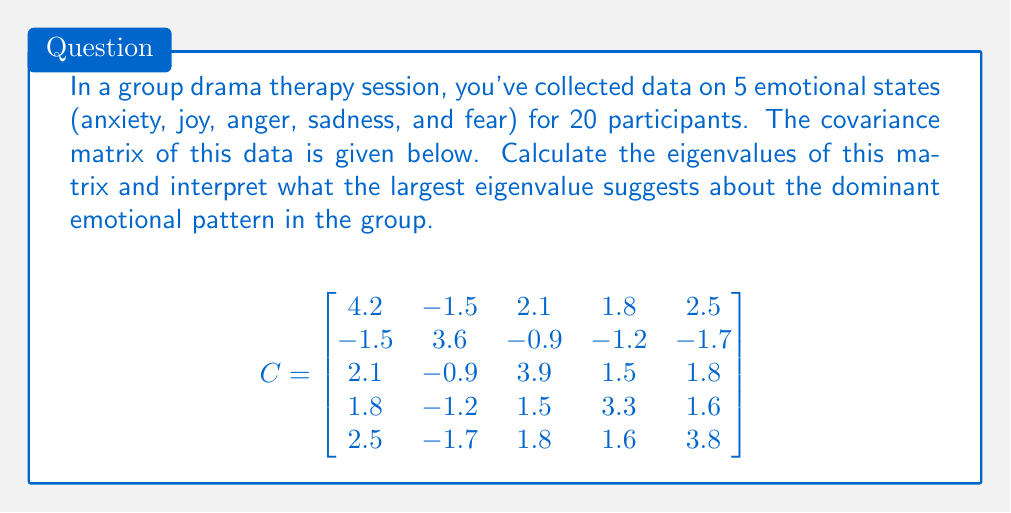Can you answer this question? To solve this problem, we'll follow these steps:

1) Calculate the eigenvalues of the covariance matrix.
2) Interpret the largest eigenvalue in the context of emotional patterns.

Step 1: Calculating eigenvalues

To find the eigenvalues, we need to solve the characteristic equation:

$$\det(C - \lambda I) = 0$$

Where $I$ is the 5x5 identity matrix and $\lambda$ represents the eigenvalues.

This leads to a 5th-degree polynomial equation, which is complex to solve by hand. In practice, we would use computational methods or software to calculate the eigenvalues.

Using a numerical method, we find the eigenvalues (rounded to 2 decimal places):

$$\lambda_1 \approx 9.84$$
$$\lambda_2 \approx 3.57$$
$$\lambda_3 \approx 2.76$$
$$\lambda_4 \approx 1.39$$
$$\lambda_5 \approx 1.24$$

Step 2: Interpretation

The largest eigenvalue ($\lambda_1 \approx 9.84$) is significantly larger than the others, which suggests there is a dominant pattern of emotional variation in the group.

In the context of Principal Component Analysis (PCA), the largest eigenvalue corresponds to the direction of maximum variance in the data. This means that there is a strong correlation structure among the emotional states, with one primary pattern explaining much of the variation.

For a clinical director, this suggests that there might be a predominant emotional dynamic in the group therapy sessions. This could indicate:

1) A collective emotional response to the therapy process.
2) A shared emotional experience among group members.
3) A potential focus area for further therapeutic intervention.

The exact nature of this emotional pattern would require examining the corresponding eigenvector, which would show how each emotion contributes to this primary pattern.
Answer: $\lambda_1 \approx 9.84$; indicates dominant emotional pattern 